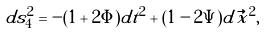Convert formula to latex. <formula><loc_0><loc_0><loc_500><loc_500>d s _ { 4 } ^ { 2 } = - ( 1 + 2 \Phi ) d t ^ { 2 } + ( 1 - 2 \Psi ) d \vec { x } ^ { 2 } ,</formula> 